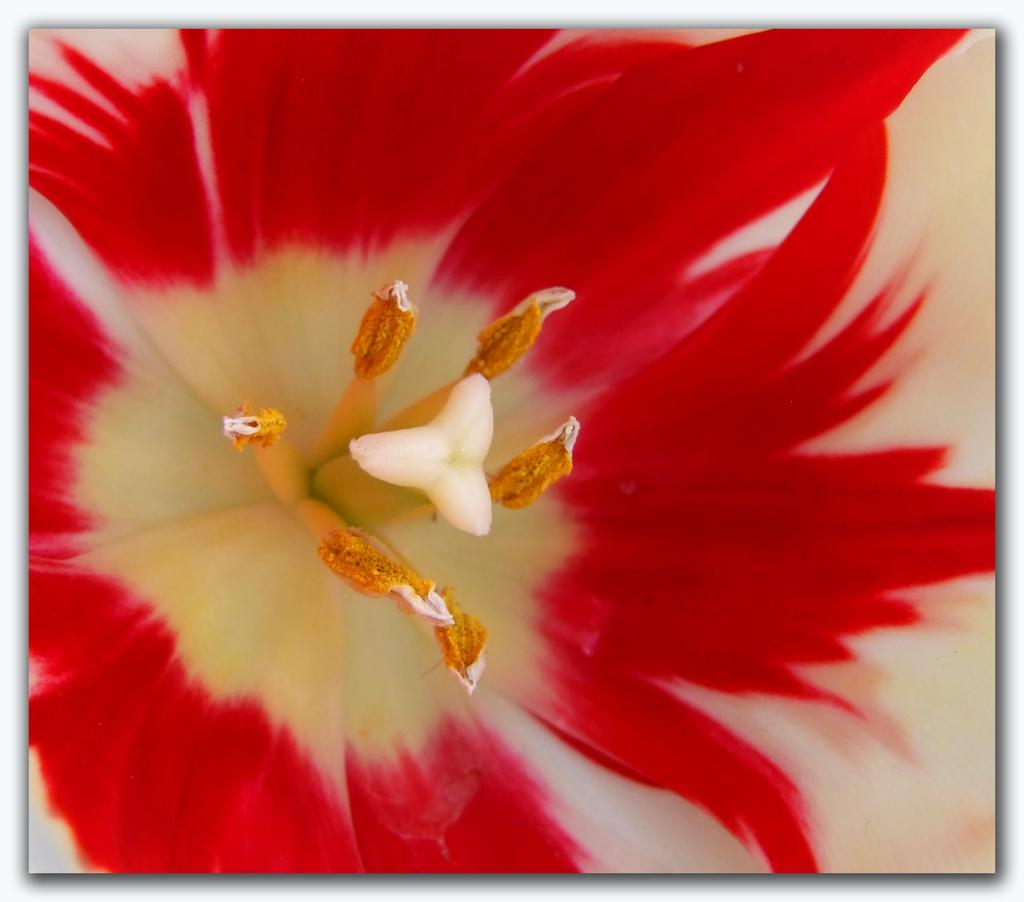What is the main subject of the image? There is a flower in the image. How many times has the flower been copied in the image? There is no indication in the image that the flower has been copied or duplicated. 